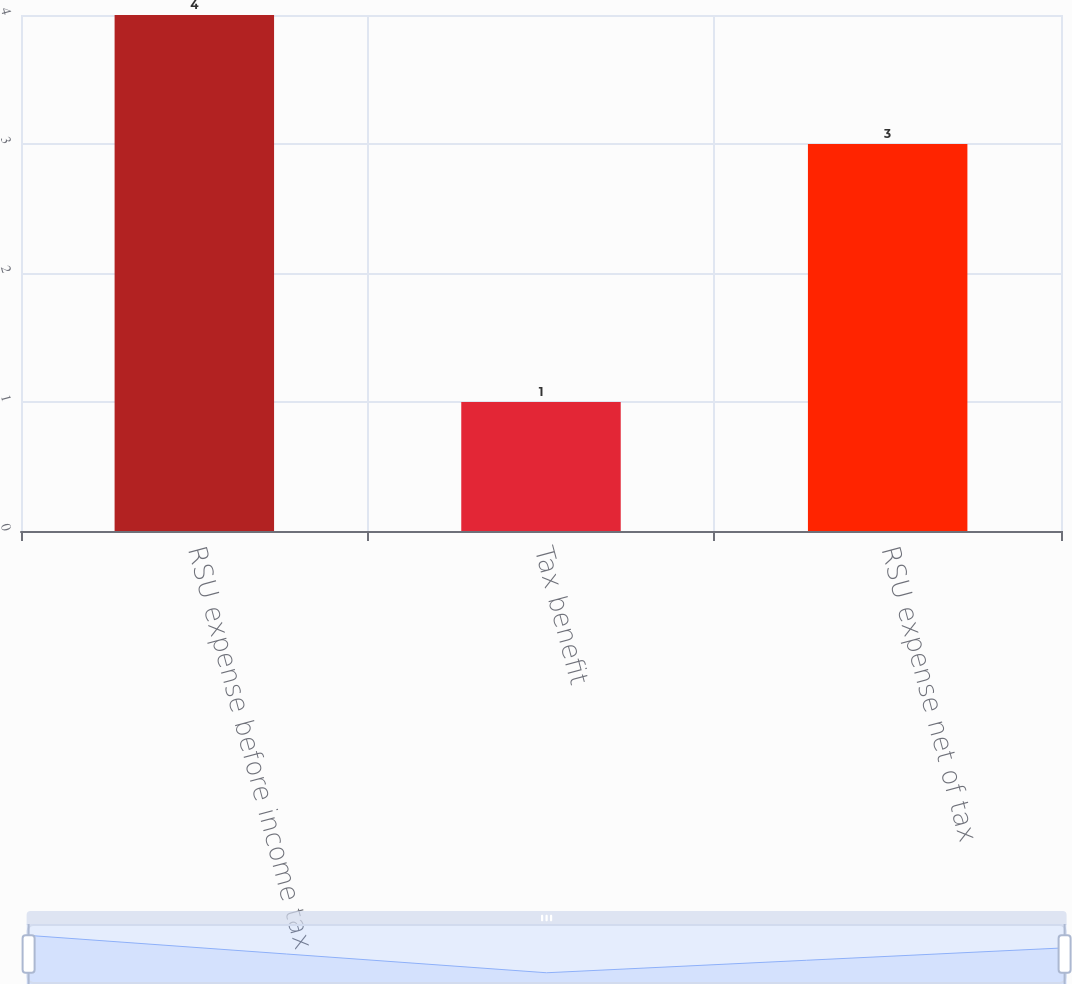Convert chart to OTSL. <chart><loc_0><loc_0><loc_500><loc_500><bar_chart><fcel>RSU expense before income tax<fcel>Tax benefit<fcel>RSU expense net of tax<nl><fcel>4<fcel>1<fcel>3<nl></chart> 